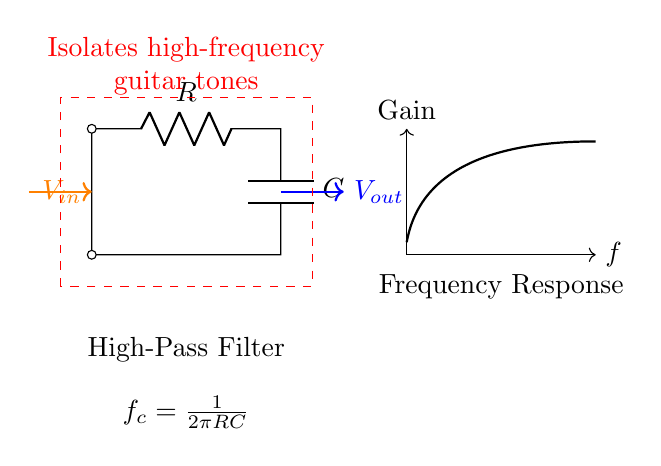What type of filter is represented in this diagram? The circuit diagram shows a high-pass filter, which is indicated by the label "High-Pass Filter." This is a type of filter that allows signals with a frequency higher than a certain cutoff frequency to pass through while attenuating signals with frequencies lower than that.
Answer: High-pass filter What components are used in the circuit? The circuit contains a resistor (R) and a capacitor (C), which are the active components of the high-pass filter. The diagram explicitly labels these components.
Answer: Resistor and capacitor How is the output voltage represented? The output voltage is represented by the label "Vout" to the right of the circuit. The arrow indicates the direction of the output flow from the circuit.
Answer: Vout What is the formula for cutoff frequency? The cutoff frequency is given by the formula "f_c = 1/(2πRC)" written in the diagram beneath the circuit. This formula indicates how the frequency response of the high-pass filter is determined by the resistor and capacitor values.
Answer: 1/(2πRC) What does the dashed rectangle in the diagram signify? The dashed rectangle highlights the area of the circuit that functions as the high-pass filter, with an annotation that explains its purpose to isolate high-frequency guitar tones. This rectangle visually separates the filter from the rest of the elements in the diagram.
Answer: Isolates high-frequency guitar tones What is the main function of this high-pass filter? The main function of this high-pass filter is to allow high-frequency guitar tones to pass while blocking lower-frequency sounds, making it suitable for electronic music settings where clarity of high notes is desired. This is emphasized by the accompanying text in the diagram.
Answer: Isolates high-frequency tones How can adjusting the resistor and capacitor values affect the circuit? Adjusting the values of the resistor (R) and capacitor (C) directly impacts the cutoff frequency according to the formula provided, hence altering the range of frequencies that can pass through the filter. A higher resistance or capacitance will lower the cutoff frequency, while a lower resistance or capacitance will raise it.
Answer: Affects cutoff frequency 